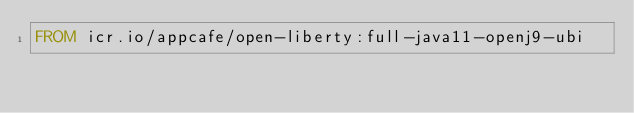Convert code to text. <code><loc_0><loc_0><loc_500><loc_500><_Dockerfile_>FROM icr.io/appcafe/open-liberty:full-java11-openj9-ubi
</code> 